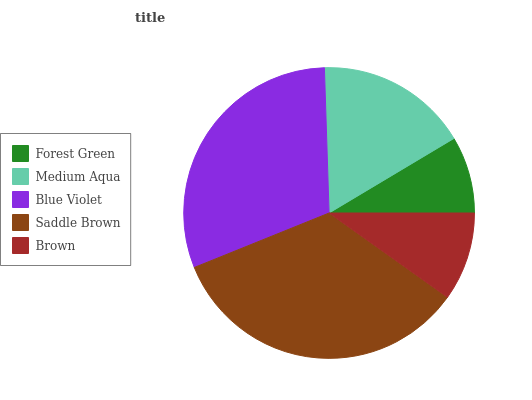Is Forest Green the minimum?
Answer yes or no. Yes. Is Saddle Brown the maximum?
Answer yes or no. Yes. Is Medium Aqua the minimum?
Answer yes or no. No. Is Medium Aqua the maximum?
Answer yes or no. No. Is Medium Aqua greater than Forest Green?
Answer yes or no. Yes. Is Forest Green less than Medium Aqua?
Answer yes or no. Yes. Is Forest Green greater than Medium Aqua?
Answer yes or no. No. Is Medium Aqua less than Forest Green?
Answer yes or no. No. Is Medium Aqua the high median?
Answer yes or no. Yes. Is Medium Aqua the low median?
Answer yes or no. Yes. Is Brown the high median?
Answer yes or no. No. Is Brown the low median?
Answer yes or no. No. 